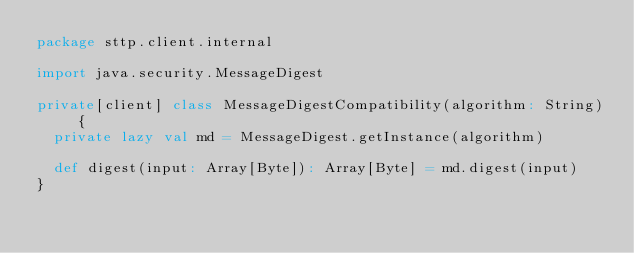<code> <loc_0><loc_0><loc_500><loc_500><_Scala_>package sttp.client.internal

import java.security.MessageDigest

private[client] class MessageDigestCompatibility(algorithm: String) {
  private lazy val md = MessageDigest.getInstance(algorithm)

  def digest(input: Array[Byte]): Array[Byte] = md.digest(input)
}
</code> 